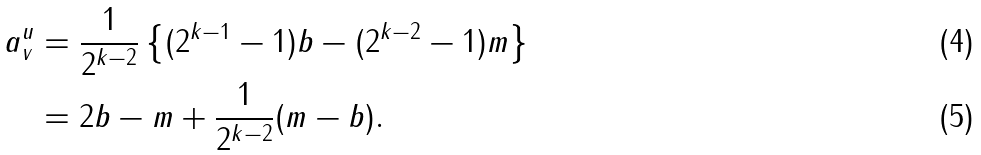Convert formula to latex. <formula><loc_0><loc_0><loc_500><loc_500>a ^ { u } _ { v } & = \frac { 1 } { 2 ^ { k - 2 } } \left \{ ( 2 ^ { k - 1 } - 1 ) b - ( 2 ^ { k - 2 } - 1 ) m \right \} \\ & = 2 b - m + \frac { 1 } { 2 ^ { k - 2 } } ( m - b ) .</formula> 